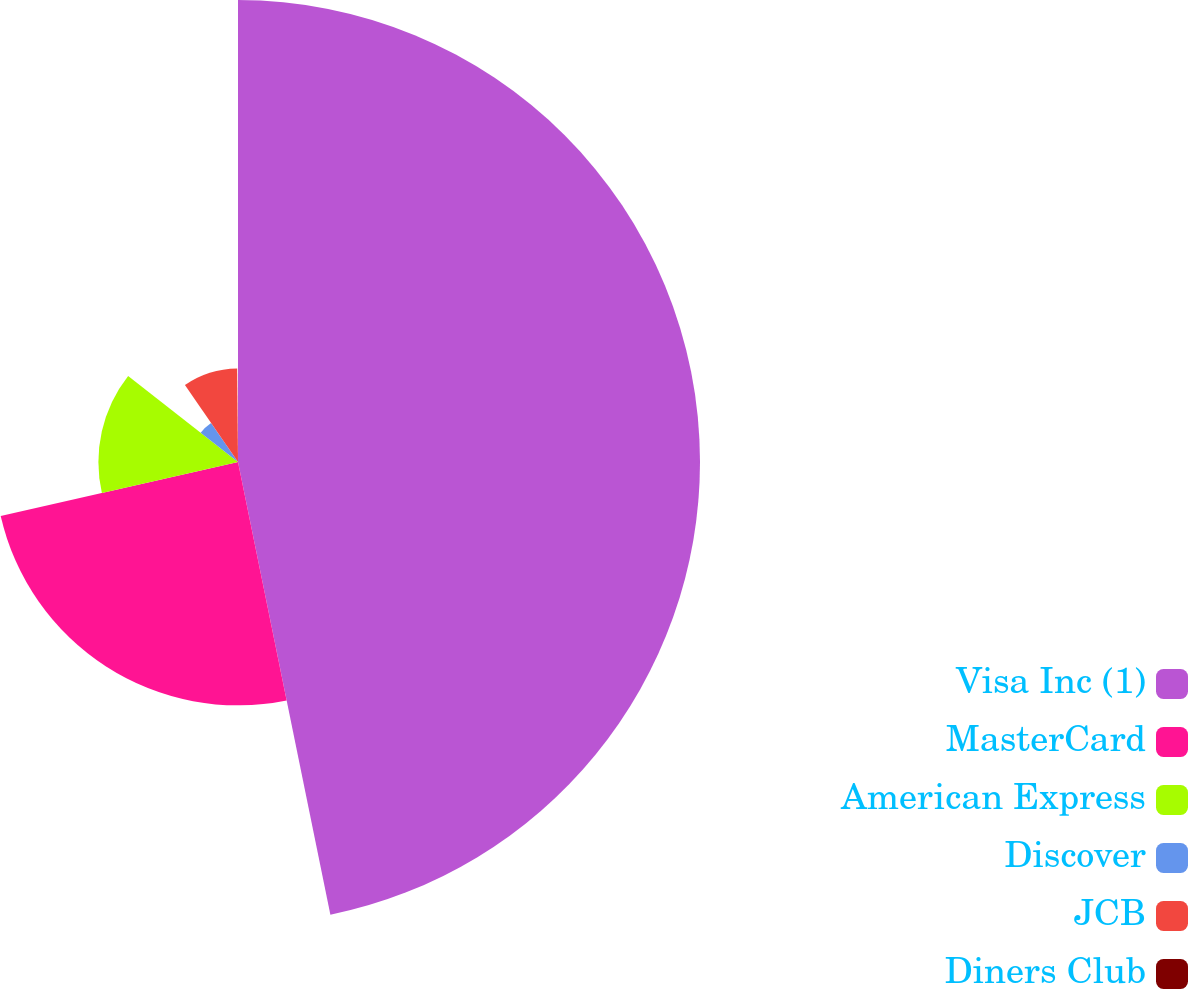Convert chart to OTSL. <chart><loc_0><loc_0><loc_500><loc_500><pie_chart><fcel>Visa Inc (1)<fcel>MasterCard<fcel>American Express<fcel>Discover<fcel>JCB<fcel>Diners Club<nl><fcel>46.8%<fcel>24.65%<fcel>14.14%<fcel>4.81%<fcel>9.47%<fcel>0.14%<nl></chart> 